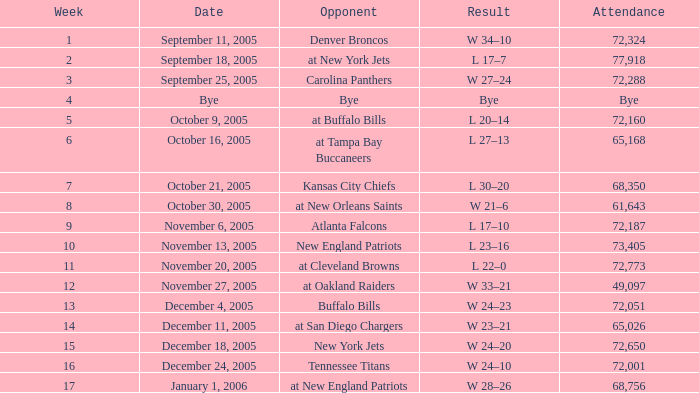Who was the Opponent on November 27, 2005? At oakland raiders. 